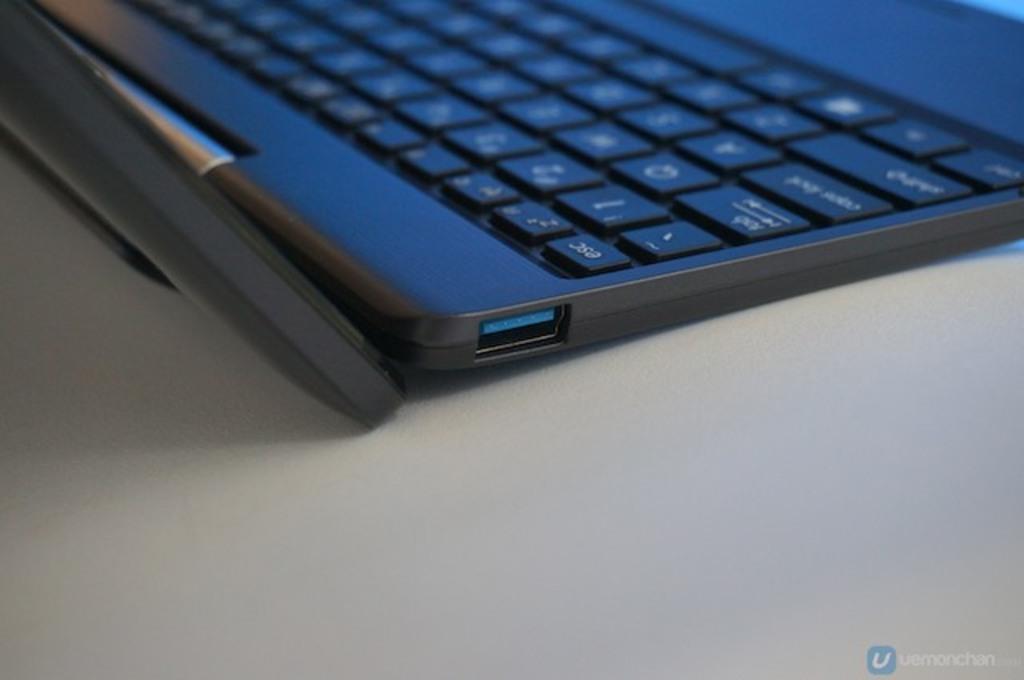Is there a q key visible on the keyboard?
Give a very brief answer. Yes. 